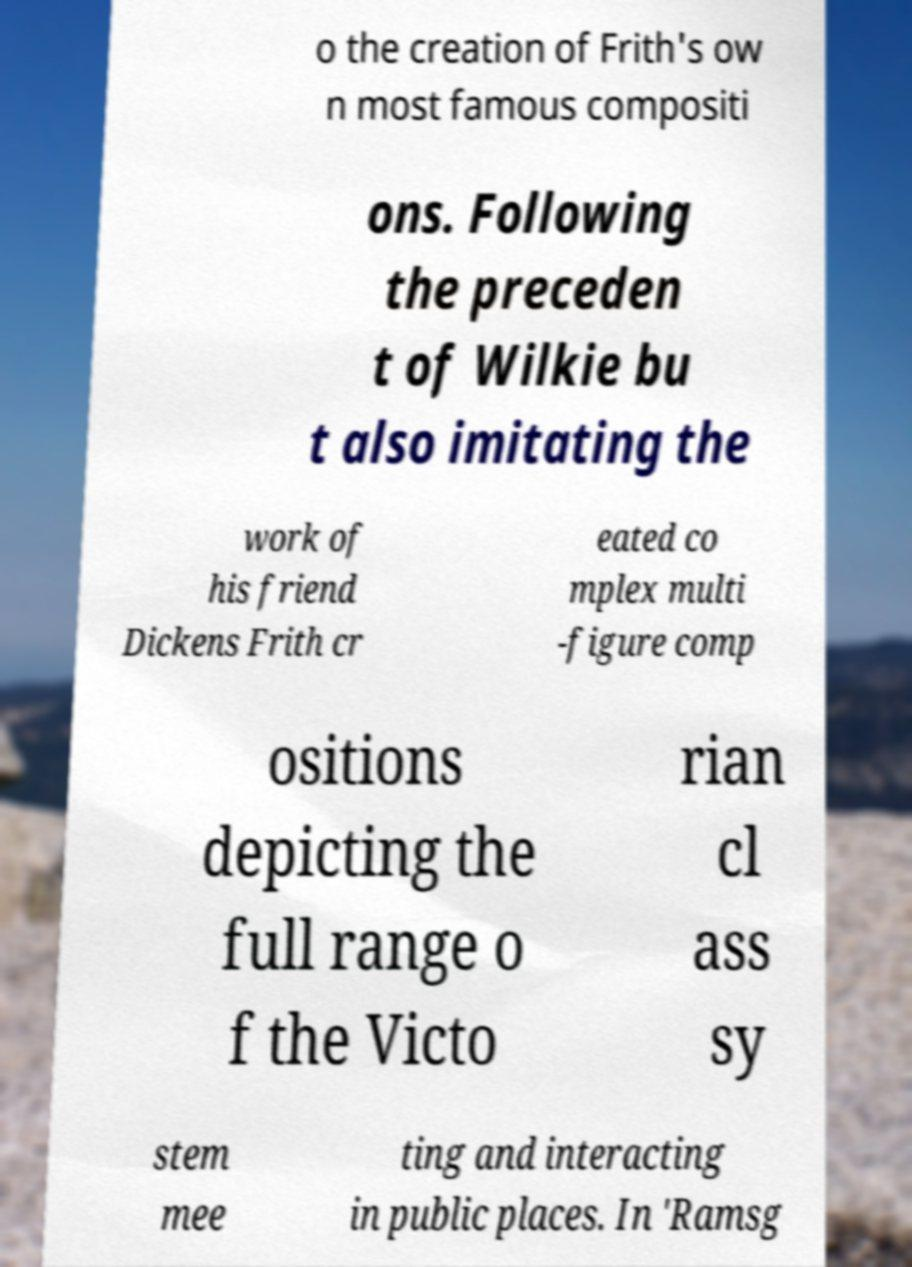Can you read and provide the text displayed in the image?This photo seems to have some interesting text. Can you extract and type it out for me? o the creation of Frith's ow n most famous compositi ons. Following the preceden t of Wilkie bu t also imitating the work of his friend Dickens Frith cr eated co mplex multi -figure comp ositions depicting the full range o f the Victo rian cl ass sy stem mee ting and interacting in public places. In 'Ramsg 